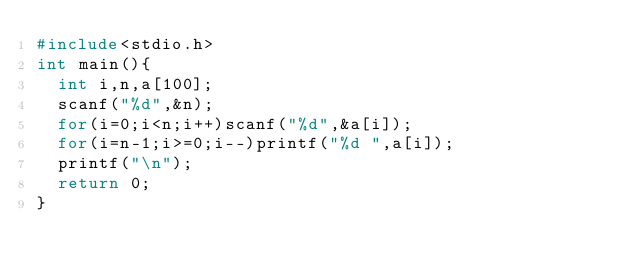Convert code to text. <code><loc_0><loc_0><loc_500><loc_500><_C_>#include<stdio.h>
int main(){
	int i,n,a[100];
	scanf("%d",&n);
	for(i=0;i<n;i++)scanf("%d",&a[i]);
	for(i=n-1;i>=0;i--)printf("%d ",a[i]);
	printf("\n");
	return 0;
}</code> 